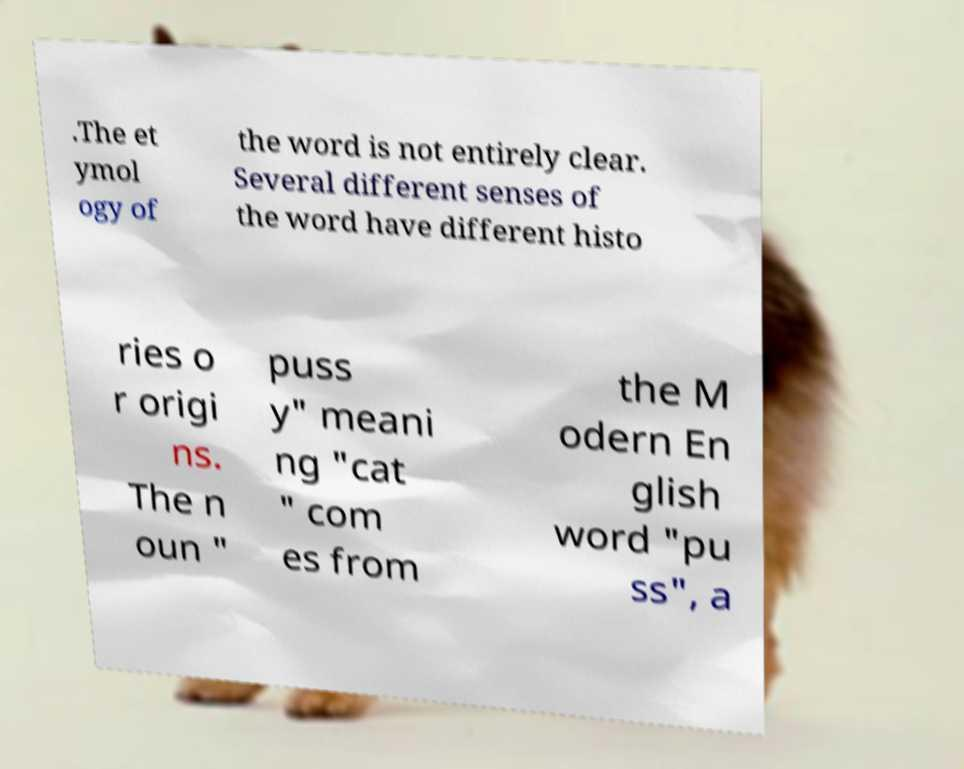What messages or text are displayed in this image? I need them in a readable, typed format. .The et ymol ogy of the word is not entirely clear. Several different senses of the word have different histo ries o r origi ns. The n oun " puss y" meani ng "cat " com es from the M odern En glish word "pu ss", a 